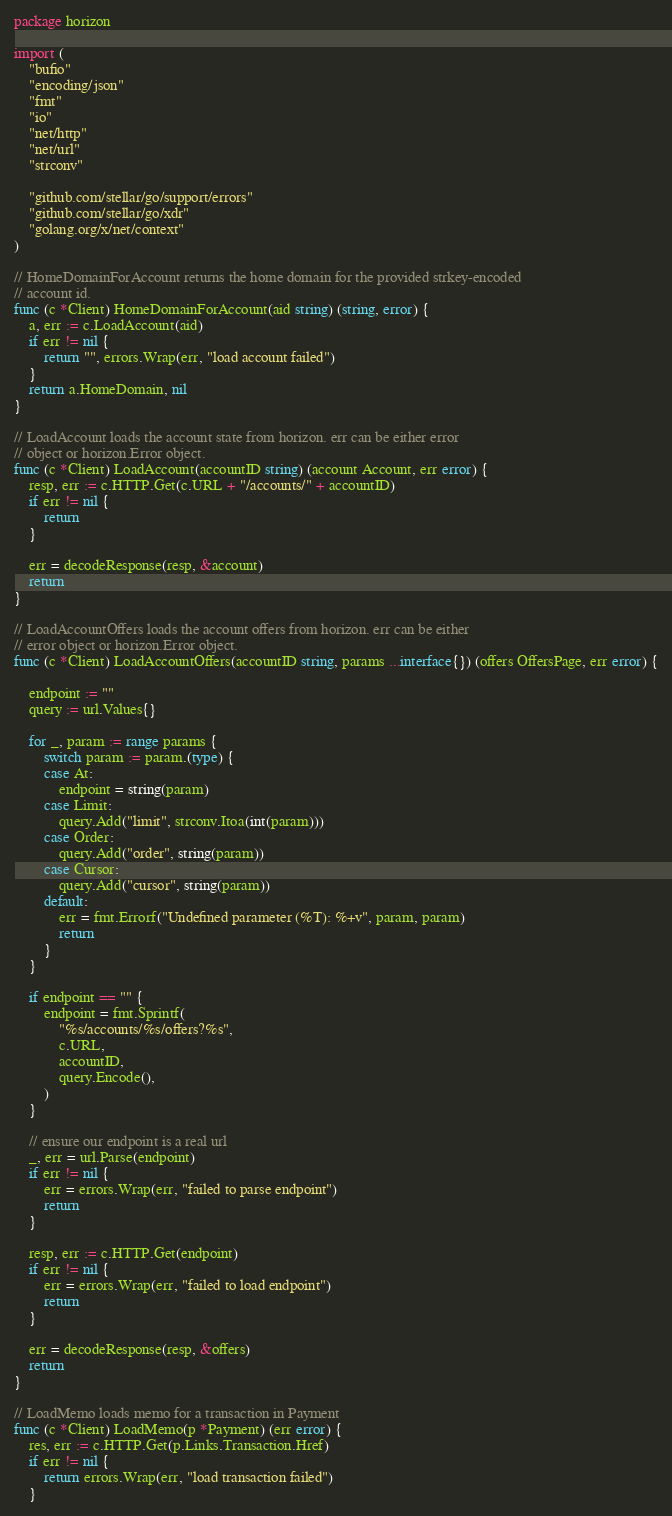<code> <loc_0><loc_0><loc_500><loc_500><_Go_>package horizon

import (
	"bufio"
	"encoding/json"
	"fmt"
	"io"
	"net/http"
	"net/url"
	"strconv"

	"github.com/stellar/go/support/errors"
	"github.com/stellar/go/xdr"
	"golang.org/x/net/context"
)

// HomeDomainForAccount returns the home domain for the provided strkey-encoded
// account id.
func (c *Client) HomeDomainForAccount(aid string) (string, error) {
	a, err := c.LoadAccount(aid)
	if err != nil {
		return "", errors.Wrap(err, "load account failed")
	}
	return a.HomeDomain, nil
}

// LoadAccount loads the account state from horizon. err can be either error
// object or horizon.Error object.
func (c *Client) LoadAccount(accountID string) (account Account, err error) {
	resp, err := c.HTTP.Get(c.URL + "/accounts/" + accountID)
	if err != nil {
		return
	}

	err = decodeResponse(resp, &account)
	return
}

// LoadAccountOffers loads the account offers from horizon. err can be either
// error object or horizon.Error object.
func (c *Client) LoadAccountOffers(accountID string, params ...interface{}) (offers OffersPage, err error) {

	endpoint := ""
	query := url.Values{}

	for _, param := range params {
		switch param := param.(type) {
		case At:
			endpoint = string(param)
		case Limit:
			query.Add("limit", strconv.Itoa(int(param)))
		case Order:
			query.Add("order", string(param))
		case Cursor:
			query.Add("cursor", string(param))
		default:
			err = fmt.Errorf("Undefined parameter (%T): %+v", param, param)
			return
		}
	}

	if endpoint == "" {
		endpoint = fmt.Sprintf(
			"%s/accounts/%s/offers?%s",
			c.URL,
			accountID,
			query.Encode(),
		)
	}

	// ensure our endpoint is a real url
	_, err = url.Parse(endpoint)
	if err != nil {
		err = errors.Wrap(err, "failed to parse endpoint")
		return
	}

	resp, err := c.HTTP.Get(endpoint)
	if err != nil {
		err = errors.Wrap(err, "failed to load endpoint")
		return
	}

	err = decodeResponse(resp, &offers)
	return
}

// LoadMemo loads memo for a transaction in Payment
func (c *Client) LoadMemo(p *Payment) (err error) {
	res, err := c.HTTP.Get(p.Links.Transaction.Href)
	if err != nil {
		return errors.Wrap(err, "load transaction failed")
	}</code> 